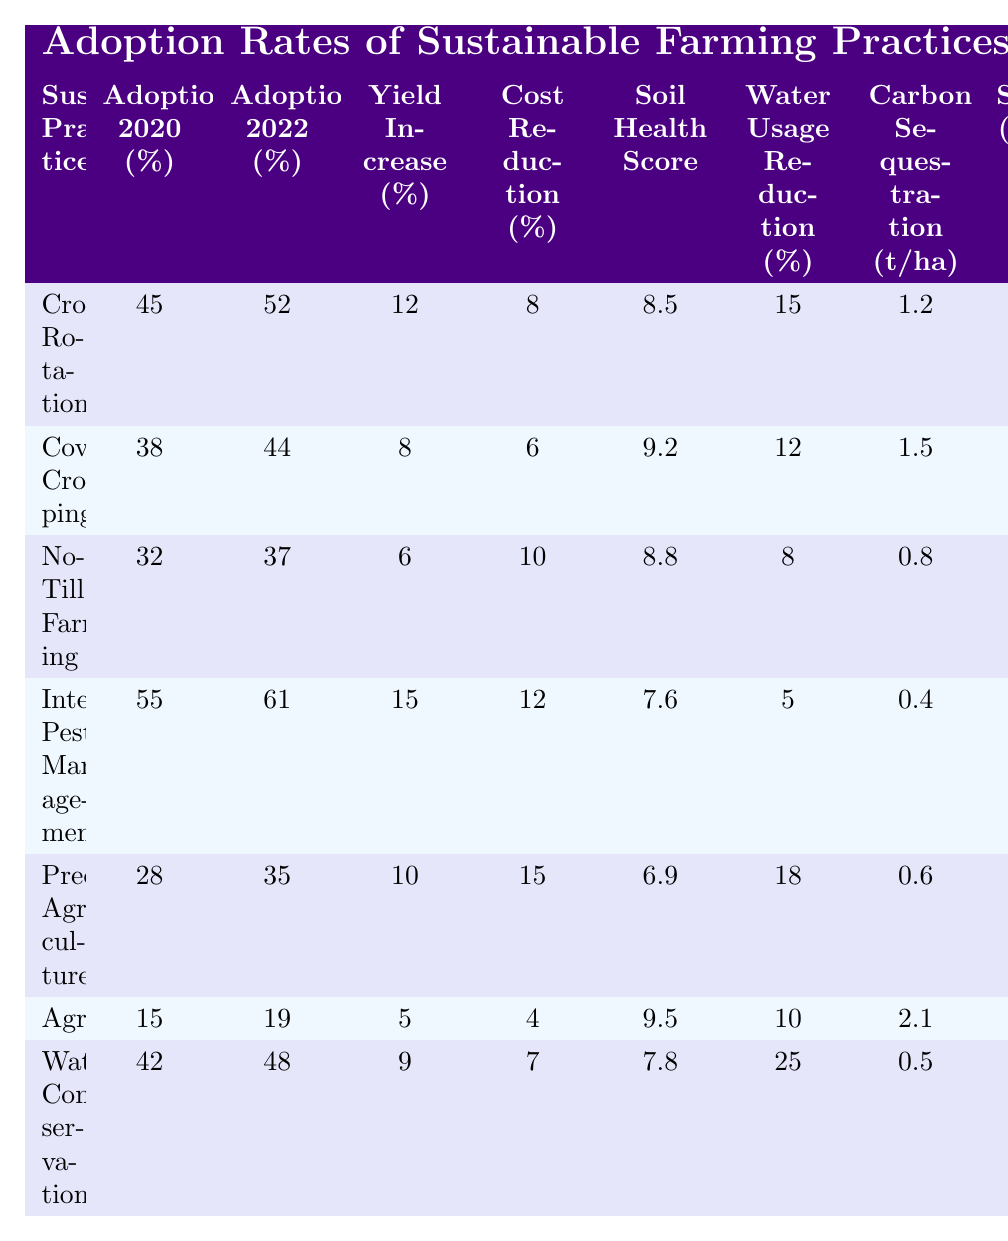What was the adoption rate of Cover Cropping in 2022? The table shows that the adoption rate for Cover Cropping in 2022 was 44%.
Answer: 44% Which sustainable practice had the highest yield increase percentage? Integrated Pest Management had the highest yield increase percentage of 15%.
Answer: Integrated Pest Management What is the average Farmer Satisfaction Score for all sustainable practices? To find the average, add the scores (7.8 + 8.2 + 7.5 + 8.5 + 8.0 + 7.2 + 8.3 = 56.5) and divide by 7 (the number of practices), which gives an average of approximately 8.07.
Answer: 8.07 Did No-Till Farming have a higher cost reduction percentage than Crop Rotation? No-Till Farming had a cost reduction percentage of 10%, which is higher than Crop Rotation's 8%.
Answer: Yes What sustainable practice had the lowest adoption rate in 2020? The sustainable practice with the lowest adoption rate in 2020 was Agroforestry, at 15%.
Answer: Agroforestry How much did the adoption rate of Water Conservation increase from 2020 to 2022? The adoption rate for Water Conservation increased from 42% in 2020 to 48% in 2022, resulting in an increase of 6%.
Answer: 6% Which sustainable practice has the highest Carbon Sequestration in tons per hectare? Agroforestry has the highest Carbon Sequestration at 2.1 tons per hectare.
Answer: Agroforestry What is the difference in Government Subsidy Amount between Precision Agriculture and Integrated Pest Management? The subsidy for Precision Agriculture is 750 USD and for Integrated Pest Management it is 350 USD. The difference is 750 - 350 = 400 USD.
Answer: 400 USD How many sustainable practices had an adoption rate higher than 40% in 2022? The sustainable practices with an adoption rate higher than 40% in 2022 are Crop Rotation, Cover Cropping, Integrated Pest Management, Water Conservation, and Precision Agriculture, totaling 5 practices.
Answer: 5 What percent of water usage reduction did Agroforestry achieve? Agroforestry achieved a water usage reduction of 10%.
Answer: 10% 